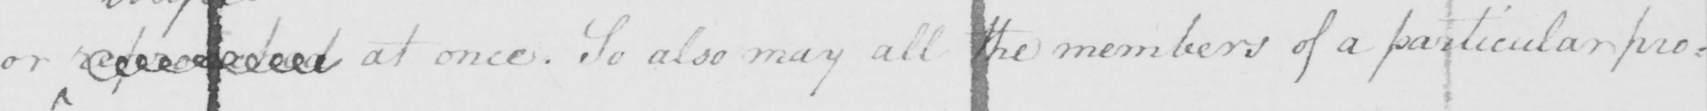What text is written in this handwritten line? or  <gap/>  at once . So also may all the members of a particular pro= 